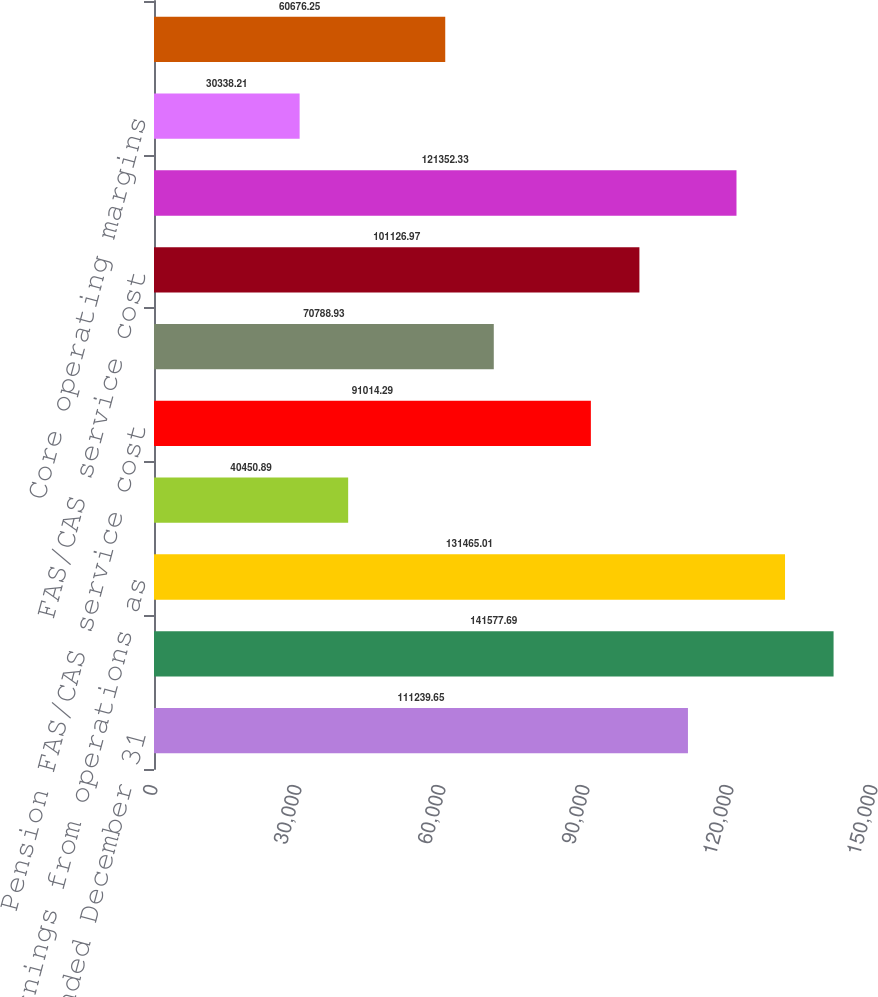Convert chart to OTSL. <chart><loc_0><loc_0><loc_500><loc_500><bar_chart><fcel>Years ended December 31<fcel>Revenues<fcel>Earnings from operations as<fcel>Operating margins<fcel>Pension FAS/CAS service cost<fcel>Postretirement FAS/CAS service<fcel>FAS/CAS service cost<fcel>Core operating earnings<fcel>Core operating margins<fcel>Diluted earnings per share as<nl><fcel>111240<fcel>141578<fcel>131465<fcel>40450.9<fcel>91014.3<fcel>70788.9<fcel>101127<fcel>121352<fcel>30338.2<fcel>60676.2<nl></chart> 